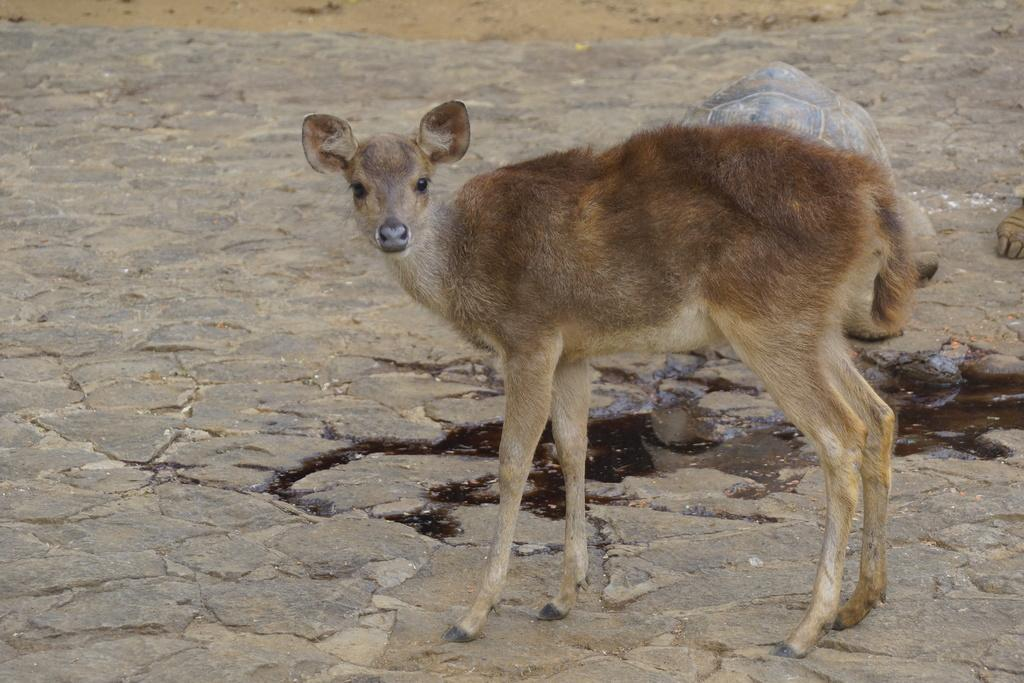What types of living organisms can be seen in the image? There are animals in the image. Where are the animals located in the image? The animals are on the ground. What type of butter can be seen on the animals in the image? There is no butter present in the image; it features animals on the ground. How many eggs are visible in the image? There are no eggs visible in the image. 